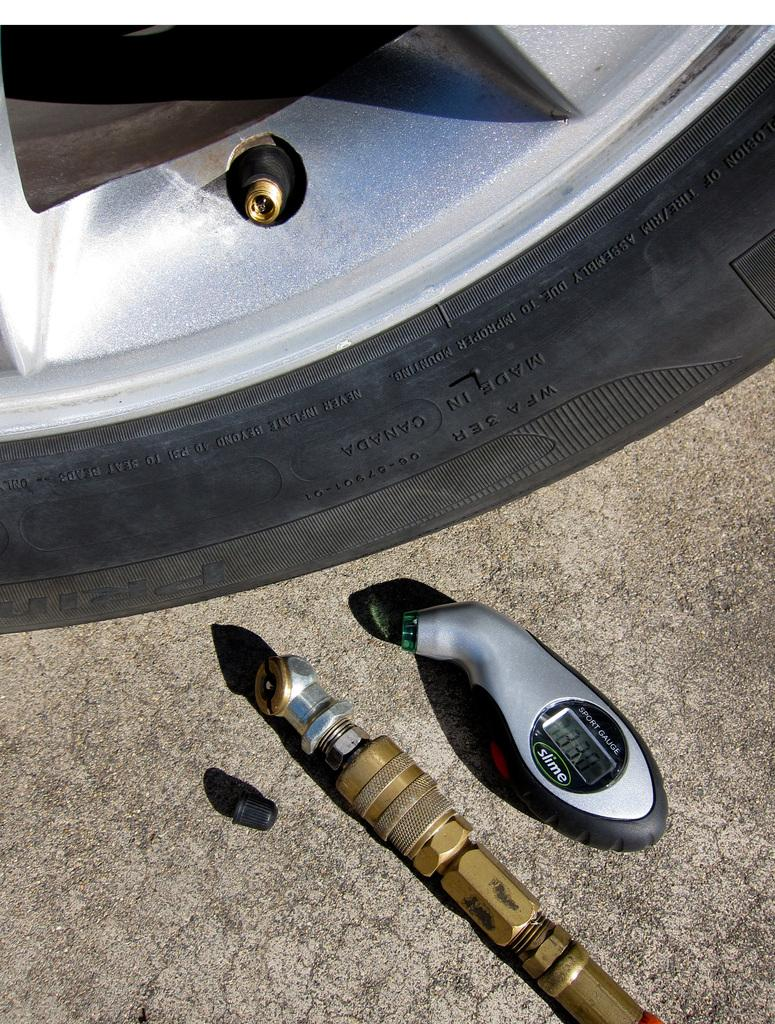What object is the main focus of the image? The main focus of the image is a car tire. What is attached to the car tire? There is a pressure measuring device attached to the tire. Are there any other objects visible in the image? Yes, there is a pipe in the image. What type of cracker is being held in the mouth of the person in the image? There is no person or cracker present in the image. 